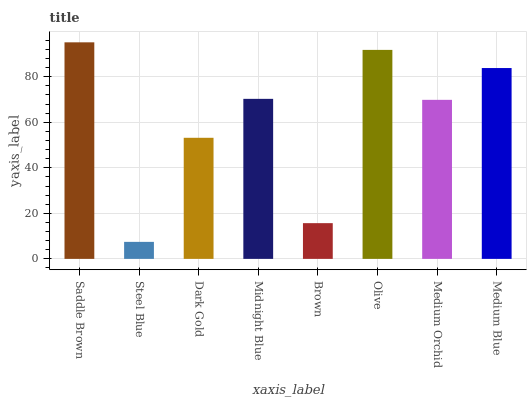Is Dark Gold the minimum?
Answer yes or no. No. Is Dark Gold the maximum?
Answer yes or no. No. Is Dark Gold greater than Steel Blue?
Answer yes or no. Yes. Is Steel Blue less than Dark Gold?
Answer yes or no. Yes. Is Steel Blue greater than Dark Gold?
Answer yes or no. No. Is Dark Gold less than Steel Blue?
Answer yes or no. No. Is Midnight Blue the high median?
Answer yes or no. Yes. Is Medium Orchid the low median?
Answer yes or no. Yes. Is Steel Blue the high median?
Answer yes or no. No. Is Steel Blue the low median?
Answer yes or no. No. 